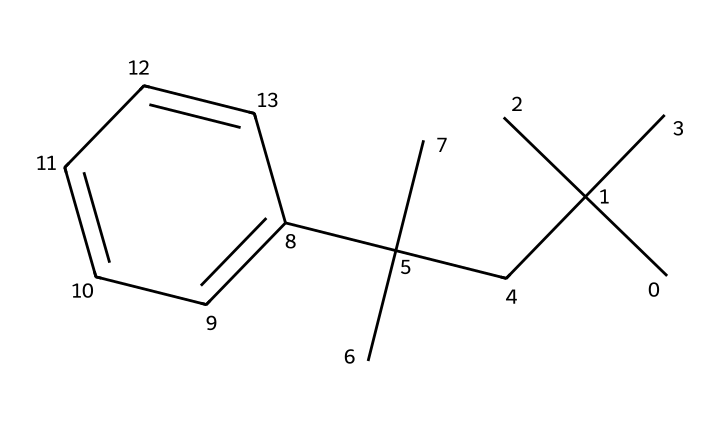What is the main component of this chemical structure? The structure depicts a substituted styrene compound showing that it is primarily made of polystyrene, a polymer of styrene.
Answer: polystyrene How many carbon atoms are in the structure? Counting the carbon atoms represented in the SMILES notation, there are 15 carbon atoms.
Answer: 15 What type of bond connects the carbon atoms in this chemical? The carbon atoms in the structure are connected by single and double covalent bonds, typical for hydrocarbon chains.
Answer: covalent What does the 'c' represent in the SMILES notation? In the SMILES notation, 'c' indicates aromatic (or cyclic) carbon atoms that are part of a benzene ring, contributing to the structure's characteristics.
Answer: aromatic What type of polymer is polystyrene? Polystyrene is a thermoplastic polymer, which means it can be melted and reshaped upon heating.
Answer: thermoplastic Is this chemical likely to be biodegradable? Polystyrene is not biodegradable; it is a plastic that can persist in the environment for many years without breaking down.
Answer: no 